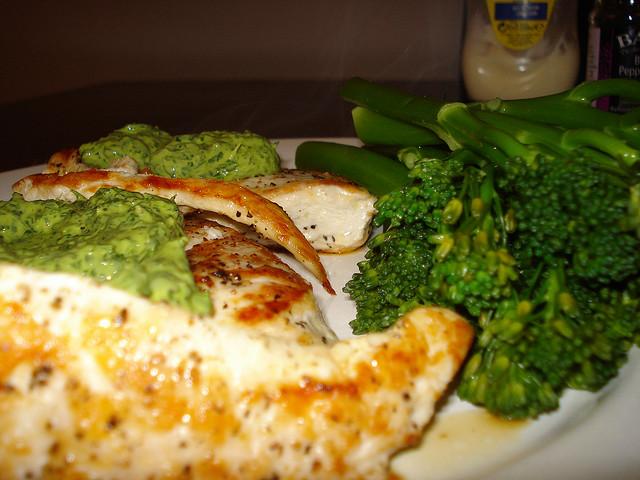What is the food sitting on?
Quick response, please. Plate. Are they having asparagus?
Be succinct. No. What is inside the bird?
Keep it brief. Pepper. Is this something one would eat for breakfast?
Concise answer only. No. Is this chicken or pork?
Write a very short answer. Chicken. What is the second vegetable?
Quick response, please. Broccoli. What kind of bird is this?
Quick response, please. Chicken. 